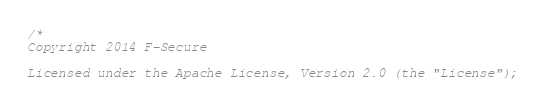<code> <loc_0><loc_0><loc_500><loc_500><_C++_>/*
Copyright 2014 F-Secure

Licensed under the Apache License, Version 2.0 (the "License");</code> 